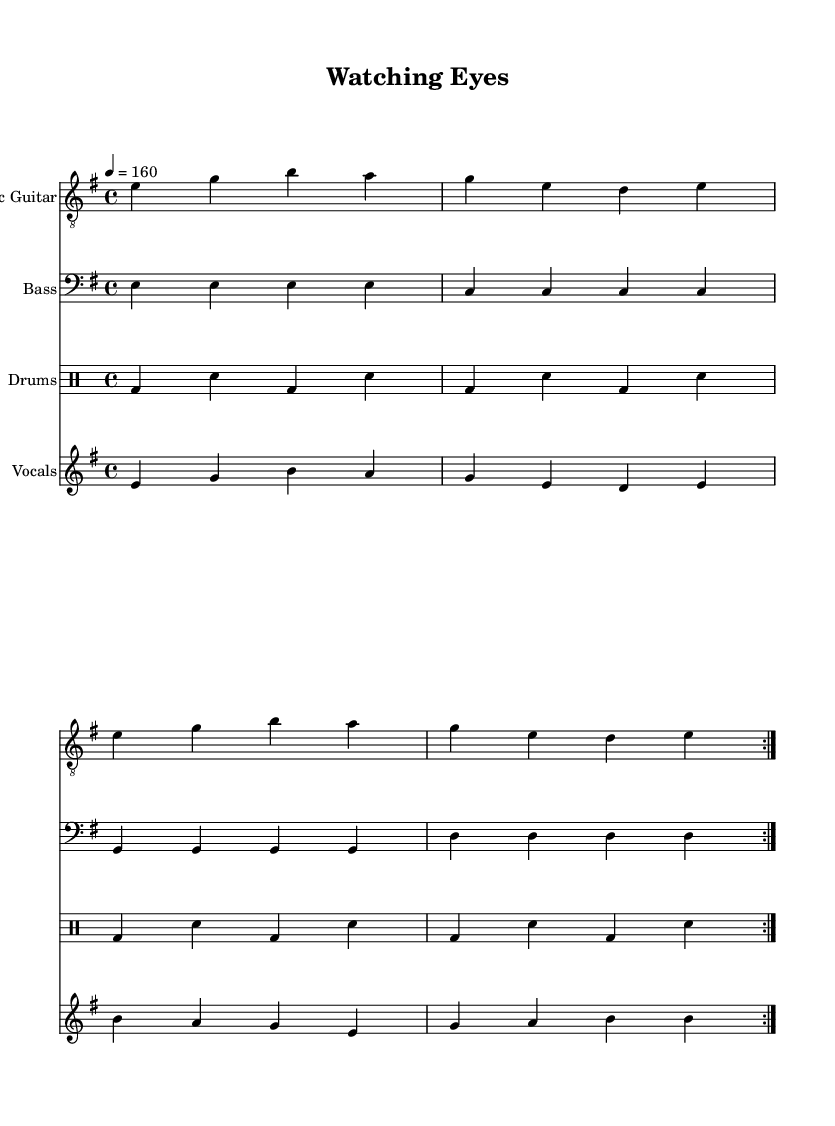What is the tempo of this music? The tempo is indicated as "4 = 160", meaning there are 160 beats per minute.
Answer: 160 What is the key signature of this piece? The key signature shown is E minor, which has one sharp (F#).
Answer: E minor What is the time signature of this music? The time signature is found at the beginning of the score and is written as "4/4", indicating four beats per measure.
Answer: 4/4 How many times is the electric guitar part repeated? The repeat mark indicates that the electric guitar part is played 2 times in total.
Answer: 2 What type of music is this piece categorized as? The style is categorized as Punk, which often reflects themes like rebellion and socio-political issues, evidenced by the lyrics about surveillance.
Answer: Punk What is the last note of the vocal part? The last note of the vocal part can be found at the end of the vocal line and is a 'b', which is a higher pitch noted in the context of the score.
Answer: b How many instruments are featured in this score? The score features four distinct instruments: electric guitar, bass, drums, and vocals, each represented on separate staves.
Answer: Four 